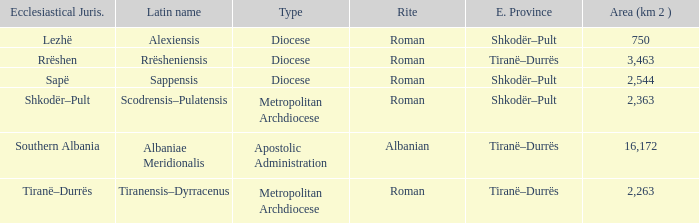What Ecclesiastical Province has a type diocese and a latin name alexiensis? Shkodër–Pult. Would you be able to parse every entry in this table? {'header': ['Ecclesiastical Juris.', 'Latin name', 'Type', 'Rite', 'E. Province', 'Area (km 2 )'], 'rows': [['Lezhë', 'Alexiensis', 'Diocese', 'Roman', 'Shkodër–Pult', '750'], ['Rrëshen', 'Rrësheniensis', 'Diocese', 'Roman', 'Tiranë–Durrës', '3,463'], ['Sapë', 'Sappensis', 'Diocese', 'Roman', 'Shkodër–Pult', '2,544'], ['Shkodër–Pult', 'Scodrensis–Pulatensis', 'Metropolitan Archdiocese', 'Roman', 'Shkodër–Pult', '2,363'], ['Southern Albania', 'Albaniae Meridionalis', 'Apostolic Administration', 'Albanian', 'Tiranë–Durrës', '16,172'], ['Tiranë–Durrës', 'Tiranensis–Dyrracenus', 'Metropolitan Archdiocese', 'Roman', 'Tiranë–Durrës', '2,263']]} 